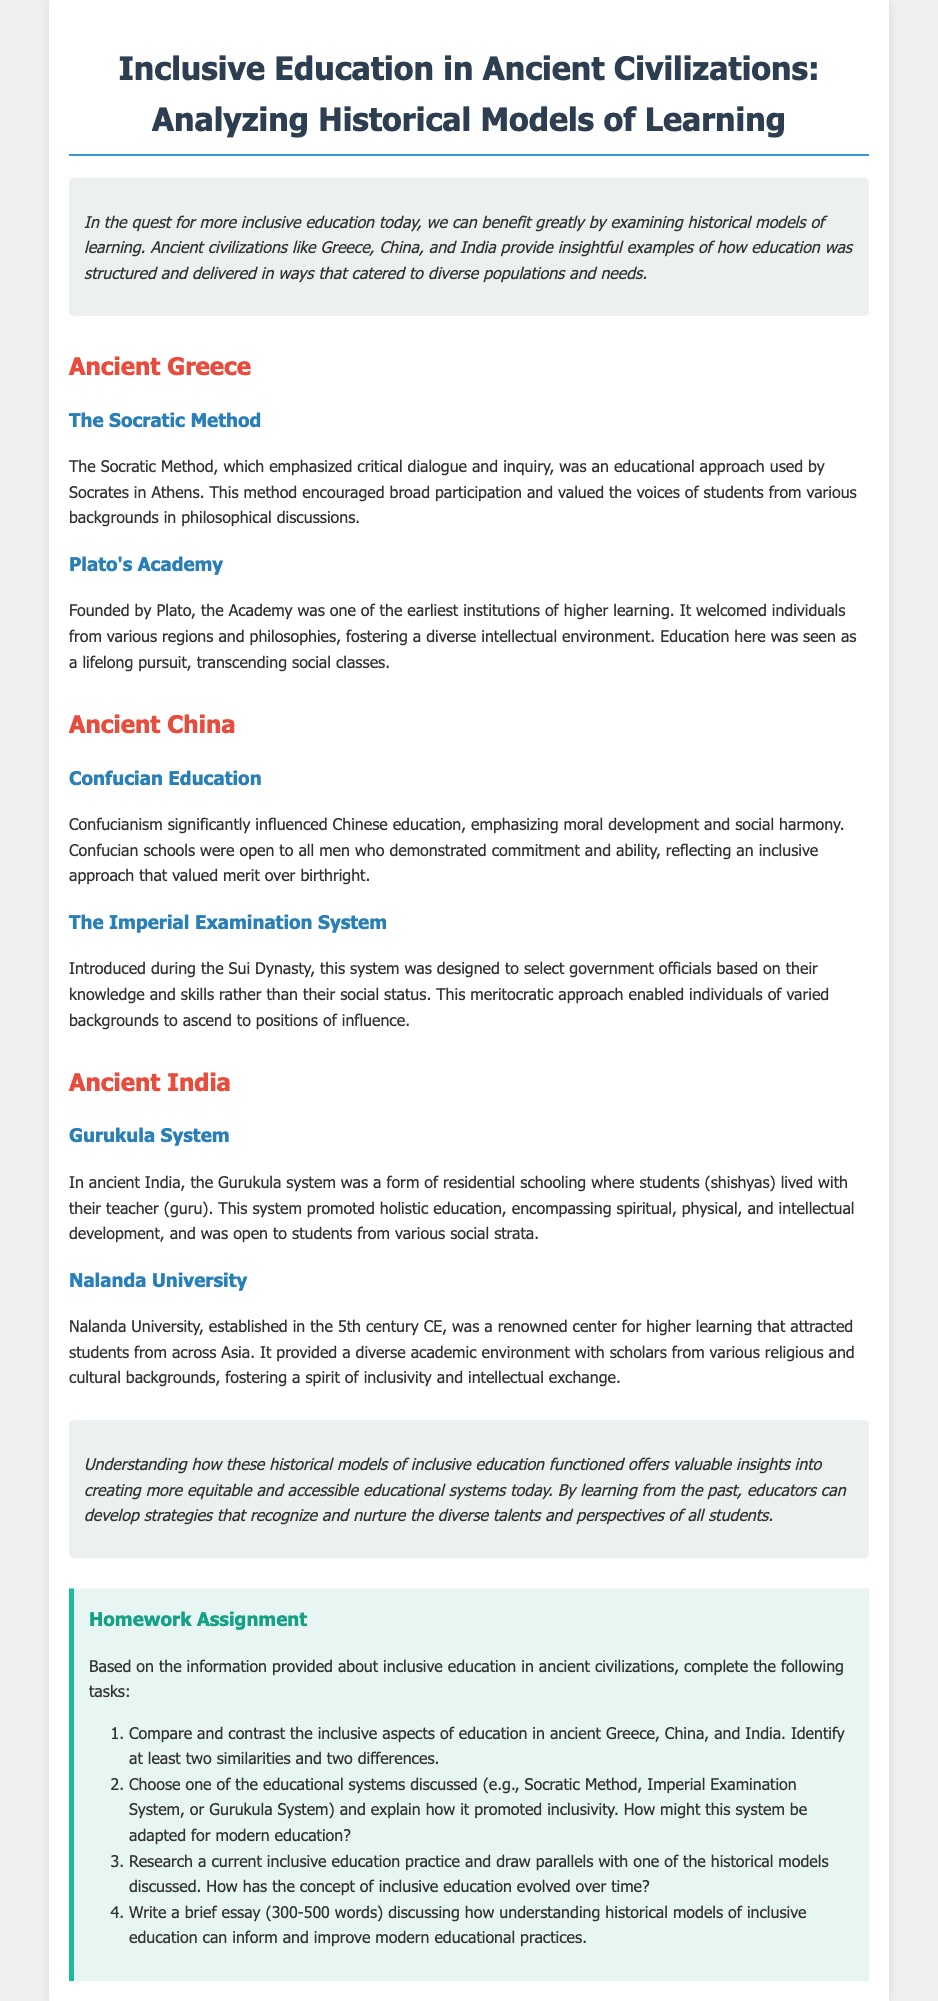What educational method did Socrates use? The document states that Socrates used the Socratic Method, which emphasized critical dialogue and inquiry.
Answer: Socratic Method What was one significant influence on Chinese education? The document mentions that Confucianism significantly influenced Chinese education by emphasizing moral development and social harmony.
Answer: Confucianism Which ancient Indian system allowed students to live with their teacher? The document explains that the Gurukula system involved students living with their teacher (guru).
Answer: Gurukula system What type of examination system was introduced during the Sui Dynasty in China? The document indicates that the Imperial Examination System was introduced during the Sui Dynasty to select government officials.
Answer: Imperial Examination System How many similarities does the homework task ask to identify between the education systems? The homework task requires identifying at least two similarities between the education systems.
Answer: Two What is the required word count for the brief essay in the homework assignment? The document specifies that the essay should be between 300-500 words.
Answer: 300-500 words Which university in ancient India attracted students from across Asia? The document states that Nalanda University was a renowned center for higher learning attracting students from across Asia.
Answer: Nalanda University What is one aspect of inclusivity promoted by the Imperial Examination System? The document explains that the Imperial Examination System enabled individuals of varied backgrounds to ascend to positions of influence.
Answer: Meritocratic approach What overarching theme is highlighted in the conclusion regarding historical models of inclusive education? The conclusion emphasizes the value of understanding historical models to improve modern educational practices.
Answer: Improve modern educational practices 